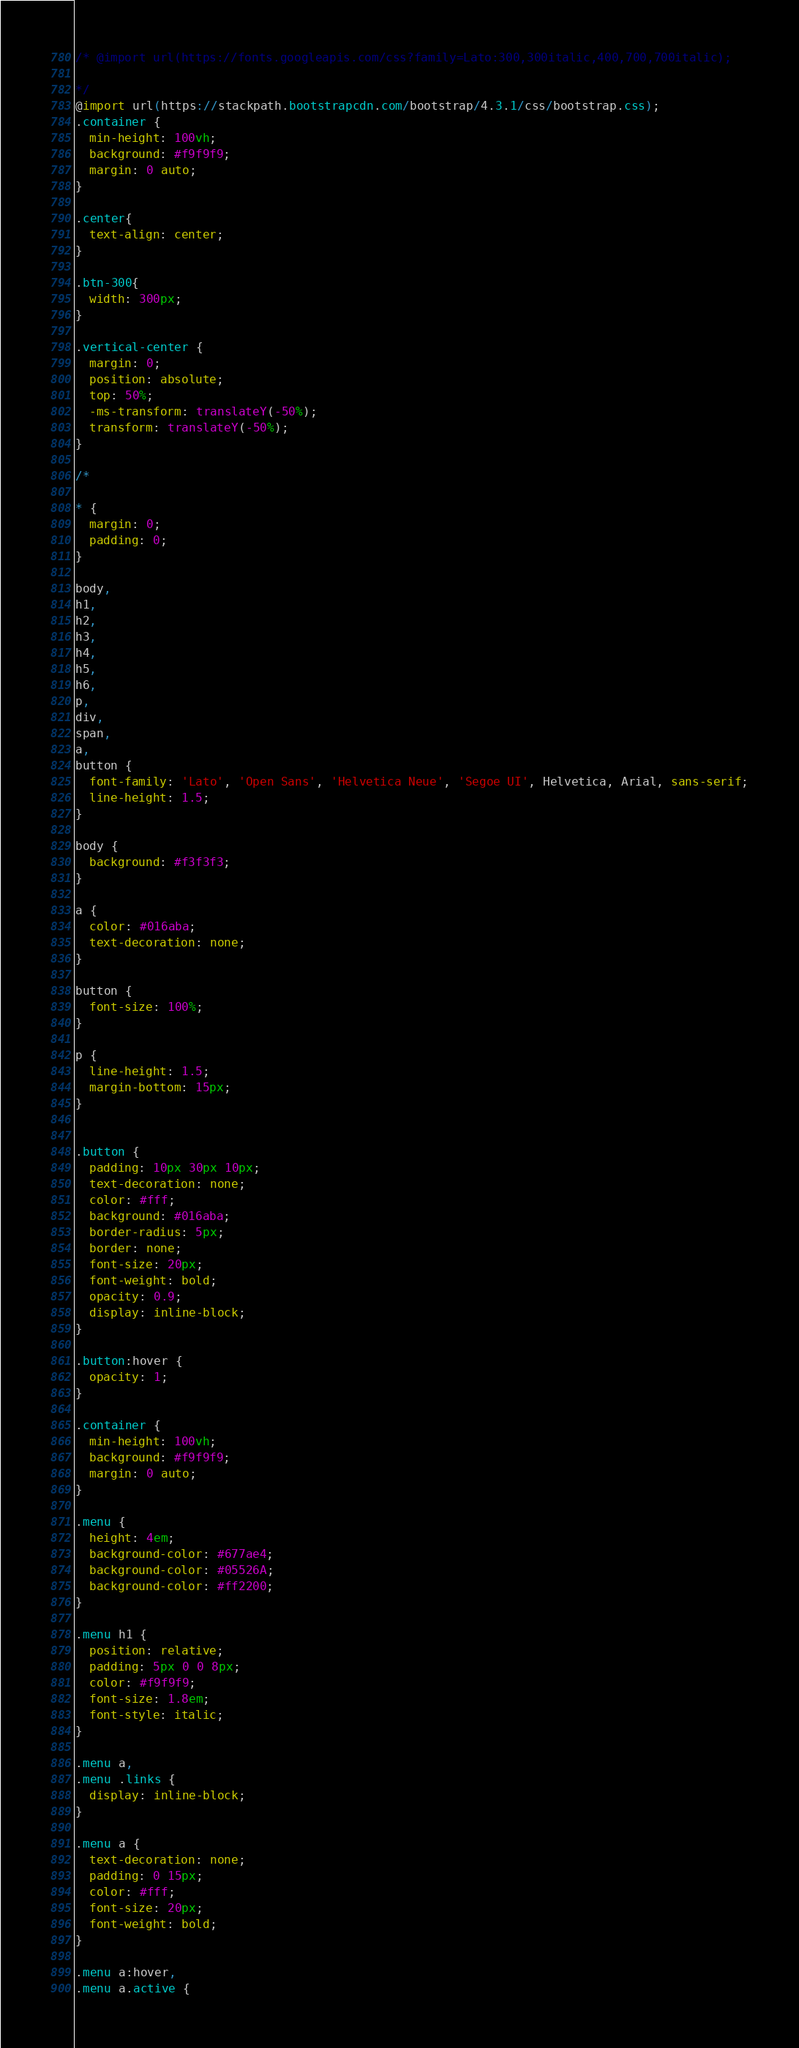<code> <loc_0><loc_0><loc_500><loc_500><_CSS_>/* @import url(https://fonts.googleapis.com/css?family=Lato:300,300italic,400,700,700italic);

*/
@import url(https://stackpath.bootstrapcdn.com/bootstrap/4.3.1/css/bootstrap.css);
.container {
  min-height: 100vh;
  background: #f9f9f9;
  margin: 0 auto;
}

.center{
  text-align: center;
}

.btn-300{
  width: 300px;
}

.vertical-center {
  margin: 0;
  position: absolute;
  top: 50%;
  -ms-transform: translateY(-50%);
  transform: translateY(-50%);
}

/*

* {
  margin: 0;
  padding: 0;
}

body,
h1,
h2,
h3,
h4,
h5,
h6,
p,
div,
span,
a,
button {
  font-family: 'Lato', 'Open Sans', 'Helvetica Neue', 'Segoe UI', Helvetica, Arial, sans-serif;
  line-height: 1.5;
}

body {
  background: #f3f3f3;
}

a {
  color: #016aba;
  text-decoration: none;
}

button {
  font-size: 100%;
}

p {
  line-height: 1.5;
  margin-bottom: 15px;
}


.button {
  padding: 10px 30px 10px;
  text-decoration: none;
  color: #fff;
  background: #016aba;
  border-radius: 5px;
  border: none;
  font-size: 20px;
  font-weight: bold;
  opacity: 0.9;
  display: inline-block;
}

.button:hover {
  opacity: 1;
}

.container {
  min-height: 100vh;
  background: #f9f9f9;
  margin: 0 auto;
}

.menu {
  height: 4em;
  background-color: #677ae4;
  background-color: #05526A;
  background-color: #ff2200;
}

.menu h1 {
  position: relative;
  padding: 5px 0 0 8px;
  color: #f9f9f9;
  font-size: 1.8em;
  font-style: italic;
}

.menu a,
.menu .links {
  display: inline-block;
}

.menu a {
  text-decoration: none;
  padding: 0 15px;
  color: #fff;
  font-size: 20px;
  font-weight: bold;
}

.menu a:hover,
.menu a.active {</code> 